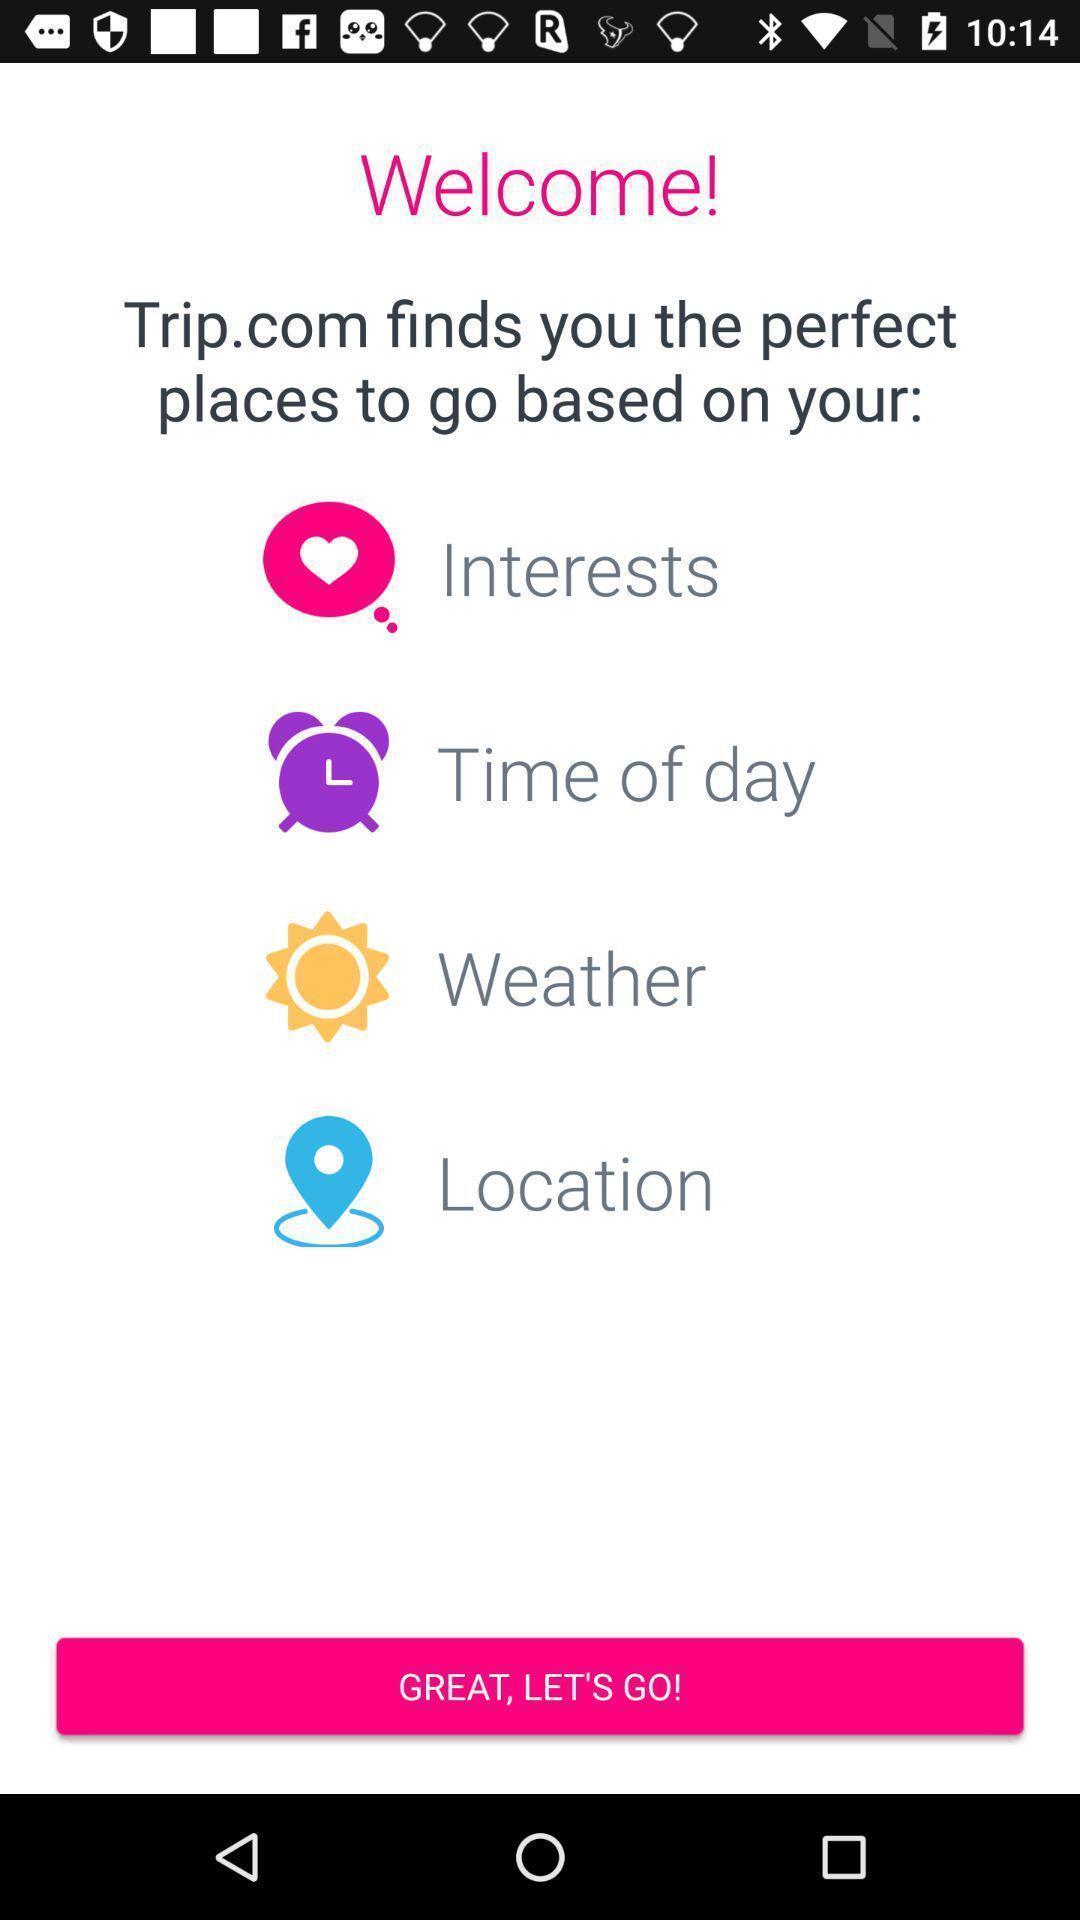Provide a description of this screenshot. Welcome page. 